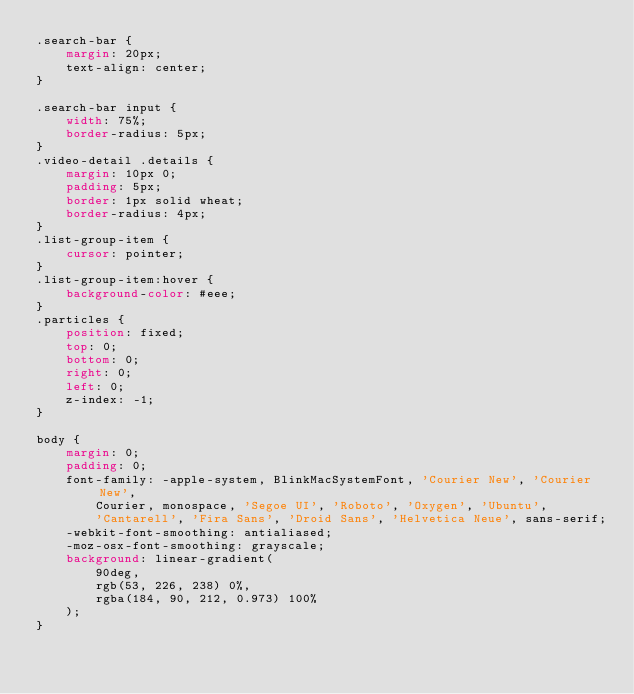Convert code to text. <code><loc_0><loc_0><loc_500><loc_500><_CSS_>.search-bar {
    margin: 20px;
    text-align: center;
}

.search-bar input {
    width: 75%;
    border-radius: 5px;
}
.video-detail .details {
    margin: 10px 0;
    padding: 5px;
    border: 1px solid wheat;
    border-radius: 4px;
}
.list-group-item {
    cursor: pointer;
}
.list-group-item:hover {
    background-color: #eee;
}
.particles {
    position: fixed;
    top: 0;
    bottom: 0;
    right: 0;
    left: 0;
    z-index: -1;
}

body {
    margin: 0;
    padding: 0;
    font-family: -apple-system, BlinkMacSystemFont, 'Courier New', 'Courier New',
        Courier, monospace, 'Segoe UI', 'Roboto', 'Oxygen', 'Ubuntu',
        'Cantarell', 'Fira Sans', 'Droid Sans', 'Helvetica Neue', sans-serif;
    -webkit-font-smoothing: antialiased;
    -moz-osx-font-smoothing: grayscale;
    background: linear-gradient(
        90deg,
        rgb(53, 226, 238) 0%,
        rgba(184, 90, 212, 0.973) 100%
    );
}
</code> 